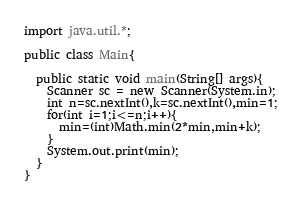<code> <loc_0><loc_0><loc_500><loc_500><_Java_>import java.util.*;

public class Main{
	
  public static void main(String[] args){
    Scanner sc = new Scanner(System.in);
  	int n=sc.nextInt(),k=sc.nextInt(),min=1;
    for(int i=1;i<=n;i++){
      min=(int)Math.min(2*min,min+k);
    }
    System.out.print(min);
  }
}
</code> 